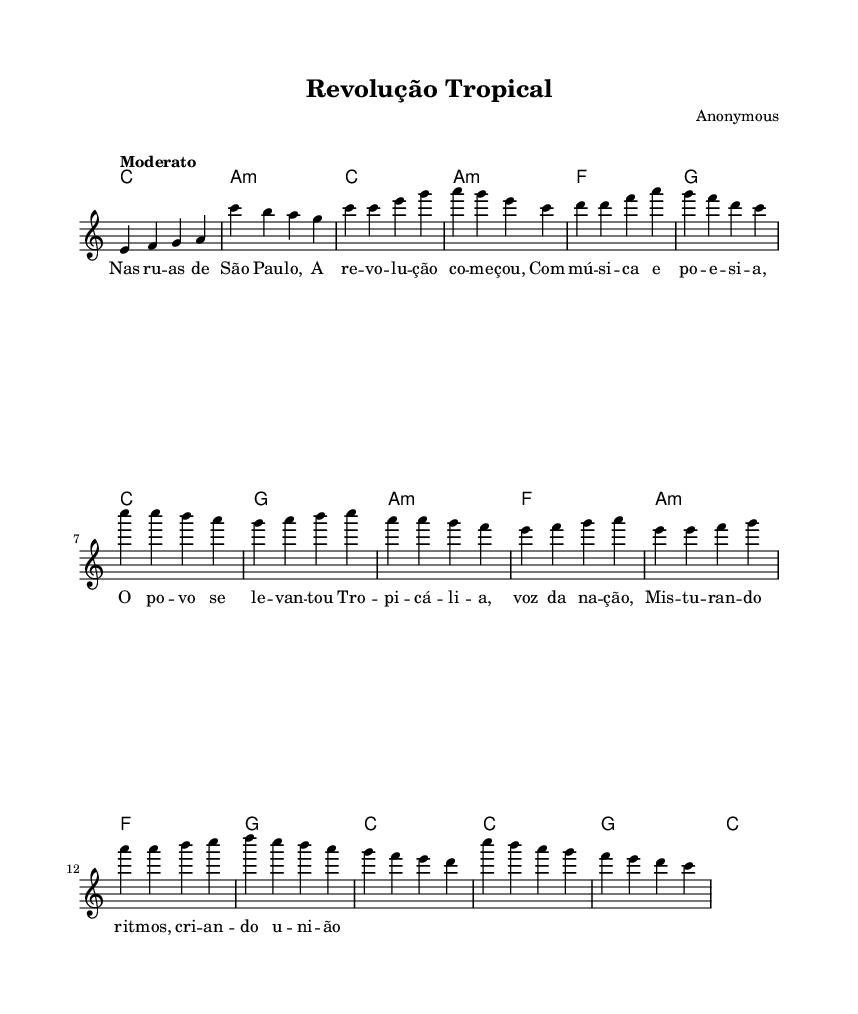What is the key signature of this music? The key signature is indicated by the 'key' command in the score, which is set to C major, meaning there are no sharps or flats.
Answer: C major What is the time signature of this music? The time signature is found in the 'time' command of the score, which specifies 4/4, indicating four beats per measure.
Answer: 4/4 What is the tempo marking for this piece? The tempo is indicated in the score with the word "Moderato," which suggests a moderately paced performance.
Answer: Moderato How many measures are in the verse section? By counting the measures in the verse part outlined in the score, four measures are present.
Answer: 4 Which chord is played during the Chorus? The Chorus section of the score begins with a C major chord, as indicated in the harmonies layer for that part.
Answer: C What cultural movement does this song represent? This song represents the Tropicália movement, which is known for blending Brazilian culture with various musical influences, reflecting social and political themes.
Answer: Tropicália Which instruments are included in this score? The score indicates the presence of a staff for the lead voice and chord names, typically implying a piano or guitar accompaniment is used alongside the voice.
Answer: Voice and chords 